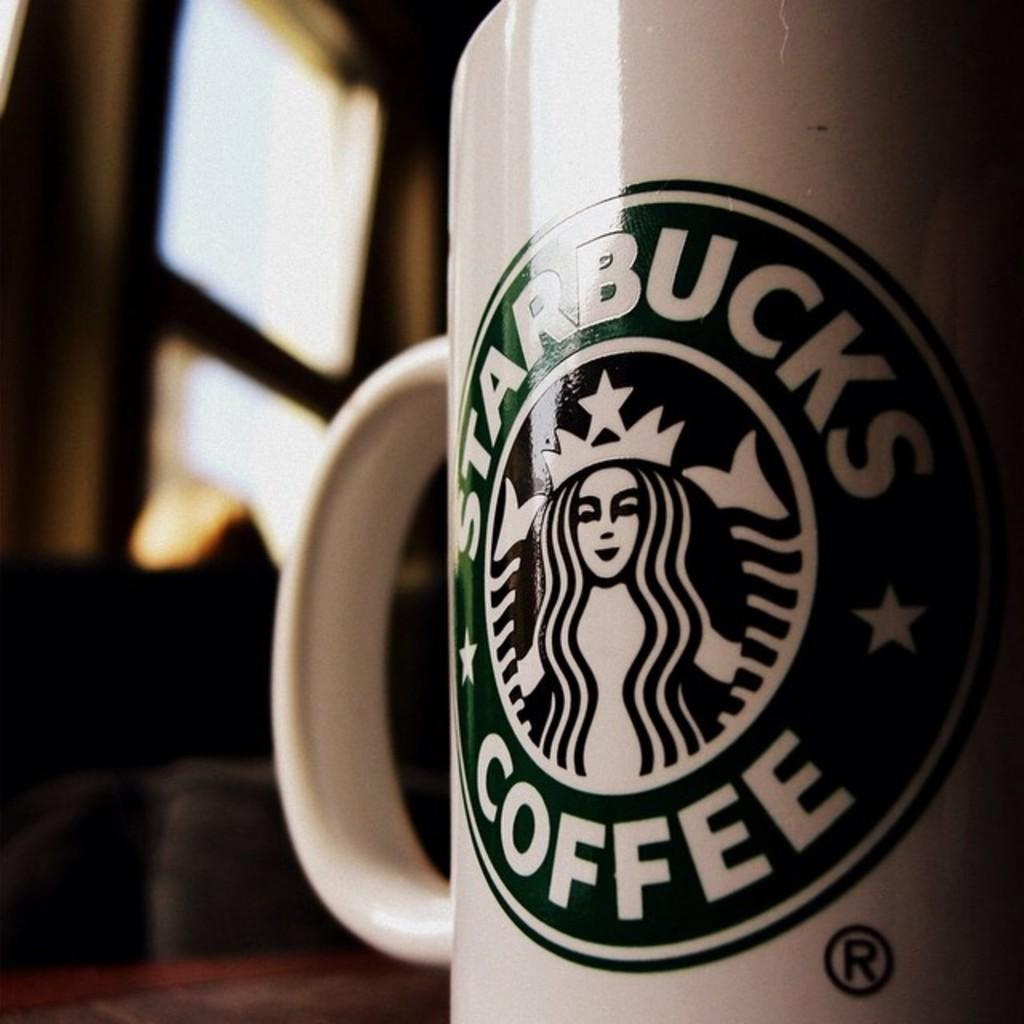What type of structure can be seen in the image? There is a wall in the image. What feature is present in the wall? There is a window in the image. What piece of furniture is visible in the image? There is a table in the image. What object is on the table? There is a white color cup on the table. What type of behavior is exhibited by the garden in the image? There is no garden present in the image, so it is not possible to determine any behavior. 